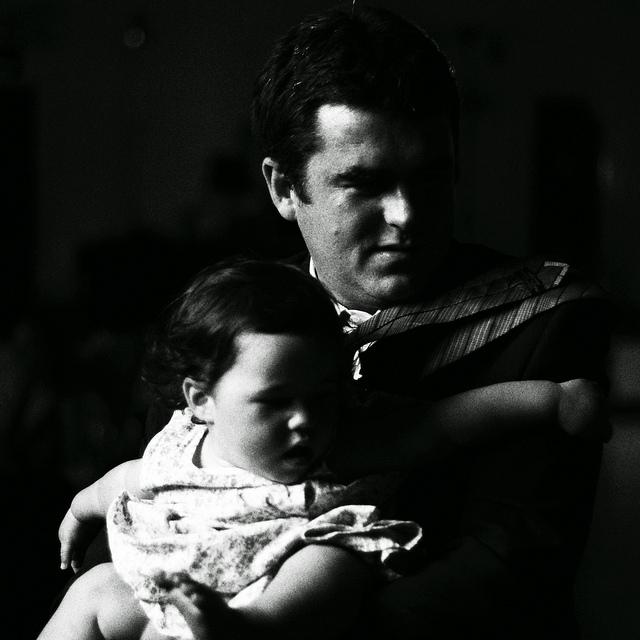What is the man holding?
Answer briefly. Baby. What is the boy riding on?
Keep it brief. Lap. How many people are in this image?
Write a very short answer. 2. Is the boy wearing a hat?
Write a very short answer. No. Does the baby seem to be female?
Short answer required. Yes. Are either of them looking at the camera?
Short answer required. No. Is the man wearing glasses?
Keep it brief. No. Does he have a mustache?
Keep it brief. No. Are these women or men?
Answer briefly. Men. Is anyone wearing sunglasses?
Concise answer only. No. 